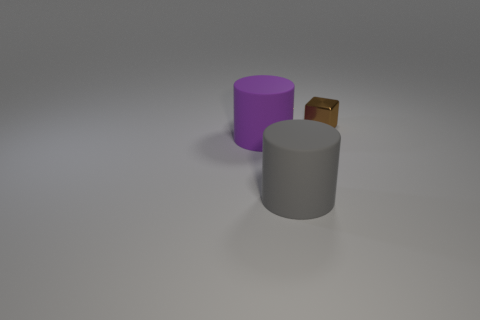Add 1 tiny brown shiny things. How many objects exist? 4 Subtract all cylinders. How many objects are left? 1 Add 2 large objects. How many large objects are left? 4 Add 2 large gray cylinders. How many large gray cylinders exist? 3 Subtract 0 yellow cylinders. How many objects are left? 3 Subtract all small purple metallic cylinders. Subtract all purple things. How many objects are left? 2 